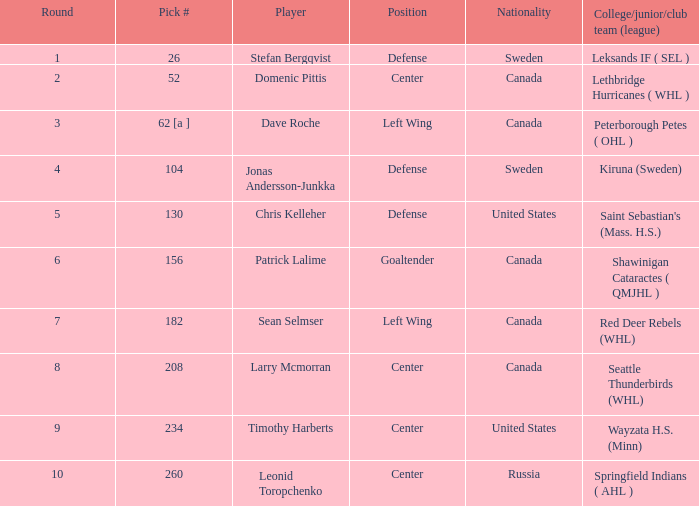What is the selection number for round 2? 52.0. 